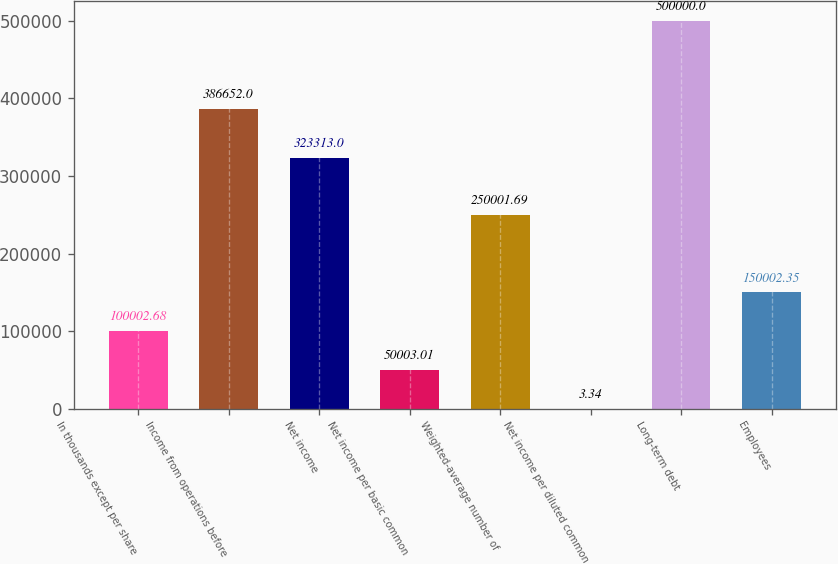<chart> <loc_0><loc_0><loc_500><loc_500><bar_chart><fcel>In thousands except per share<fcel>Income from operations before<fcel>Net income<fcel>Net income per basic common<fcel>Weighted-average number of<fcel>Net income per diluted common<fcel>Long-term debt<fcel>Employees<nl><fcel>100003<fcel>386652<fcel>323313<fcel>50003<fcel>250002<fcel>3.34<fcel>500000<fcel>150002<nl></chart> 